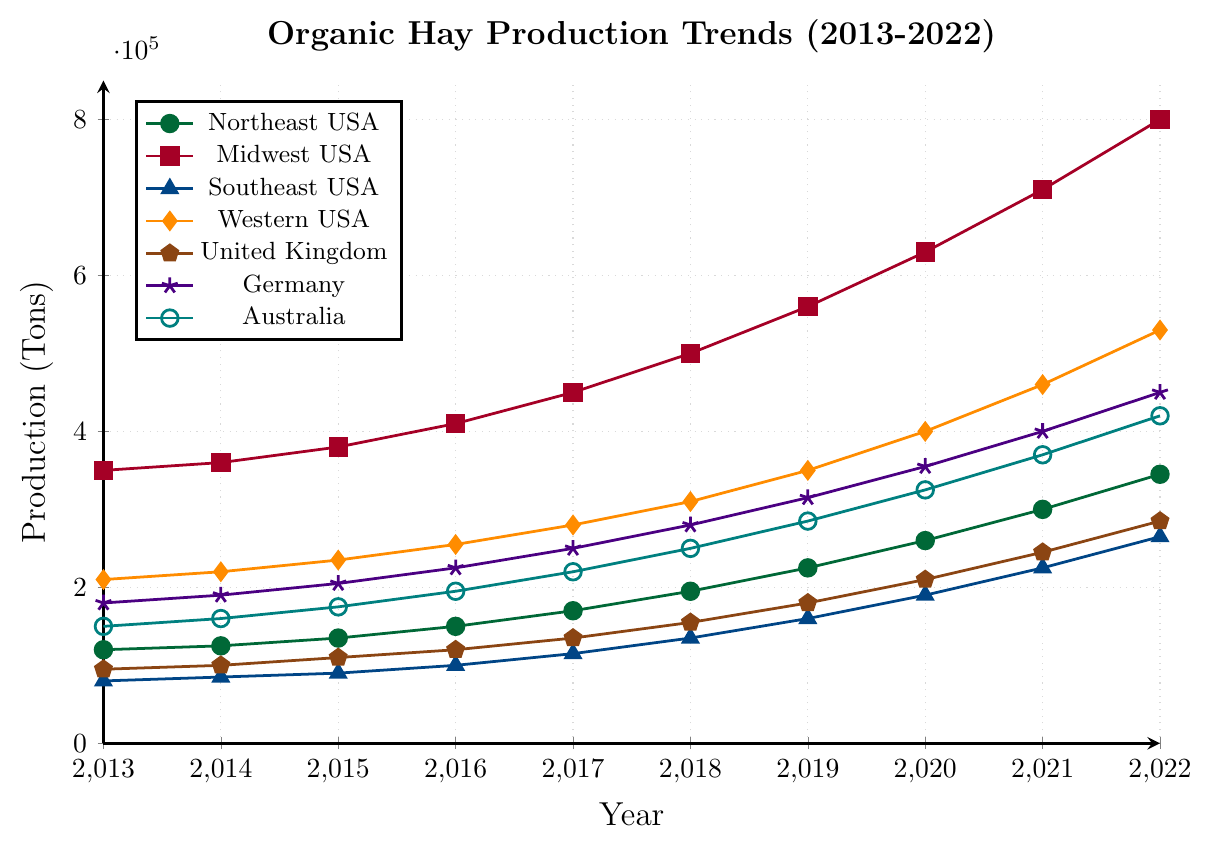What region had the highest organic hay production in 2022? The highest point on the graph in 2022 is for the Midwest USA line, indicating that it had the highest production.
Answer: Midwest USA Which two regions saw the largest increase in organic hay production from 2013 to 2022? To find the largest increases, compare the amounts from 2013 to 2022 for each region. The largest differences are found in Midwest USA (800,000 - 350,000 = 450,000) and Western USA (530,000 - 210,000 = 320,000).
Answer: Midwest USA and Western USA By how much did the production in the Southeast USA increase between 2016 and 2021? In 2016, the production in Southeast USA was 100,000 tons, and in 2021, it was 225,000 tons. The difference is 225,000 - 100,000 = 125,000 tons.
Answer: 125,000 tons What is the average organic hay production in Germany over the given years? Sum the values for Germany from 2013 to 2022 and divide by the number of years: (180,000 + 190,000 + 205,000 + 225,000 + 250,000 + 280,000 + 315,000 + 355,000 + 400,000 + 450,000) / 10 = 285,000 tons.
Answer: 285,000 tons Which region showed consistent year-on-year growth without any fluctuations? The graph lines that are smooth and consistently increasing without any dips need to be identified. All regions except Germany show smooth year-on-year growth. Camera footage shows that the segments are quite consistent except for Germany.
Answer: All regions except Germany Which region had the smallest total production growth from 2013 to 2022? Calculate the increase for each region by subtracting the 2013 value from the 2022 value. The region with the smallest increase is United Kingdom (285,000 - 95,000 = 190,000).
Answer: United Kingdom In what year did the Western USA surpass 300,000 tons of organic hay production? Trace the production line for Western USA and identify the year it crosses the 300,000 tons mark. This occurred in 2018.
Answer: 2018 By what amount did the organic hay production in the United Kingdom grow from 2019 to 2022? Subtract the 2019 value from the 2022 value for the United Kingdom: 285,000 - 180,000 = 105,000 tons.
Answer: 105,000 tons 